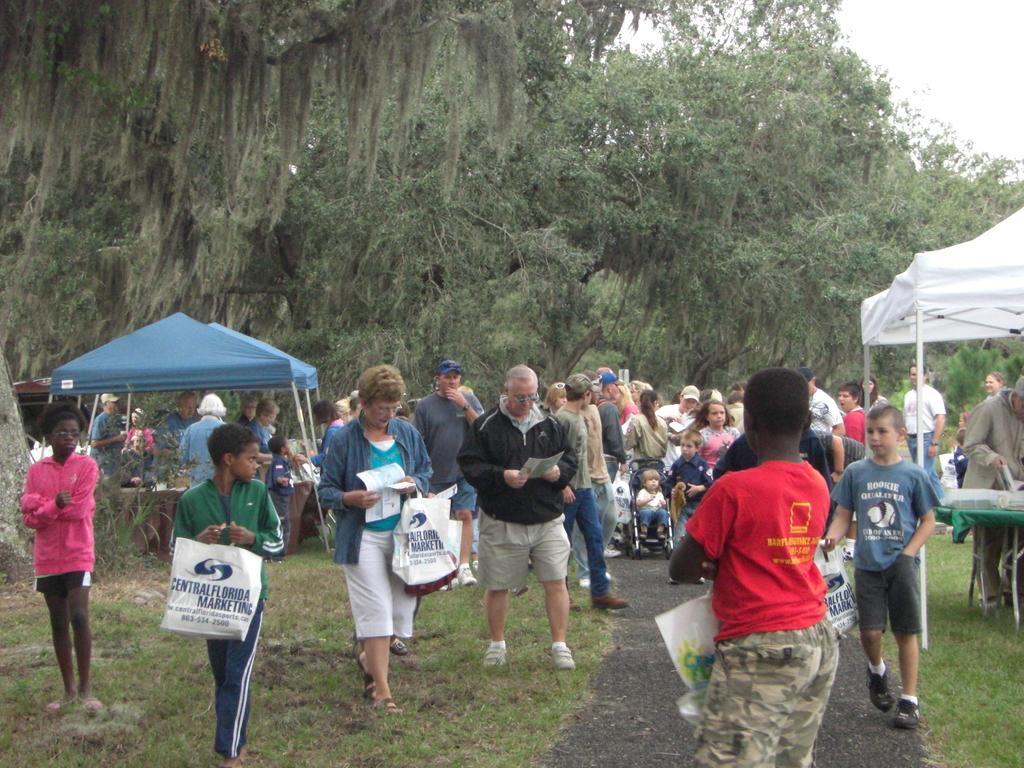What are the people in the image holding? The people in the image are holding carry bags. What can be seen in the background of the image? There are trees visible in the image. What objects are present at the back of the image? There are umbrellas at the back. Where is the tub located in the image? There is no tub present in the image. How many horses can be seen in the image? There are no horses present in the image. 